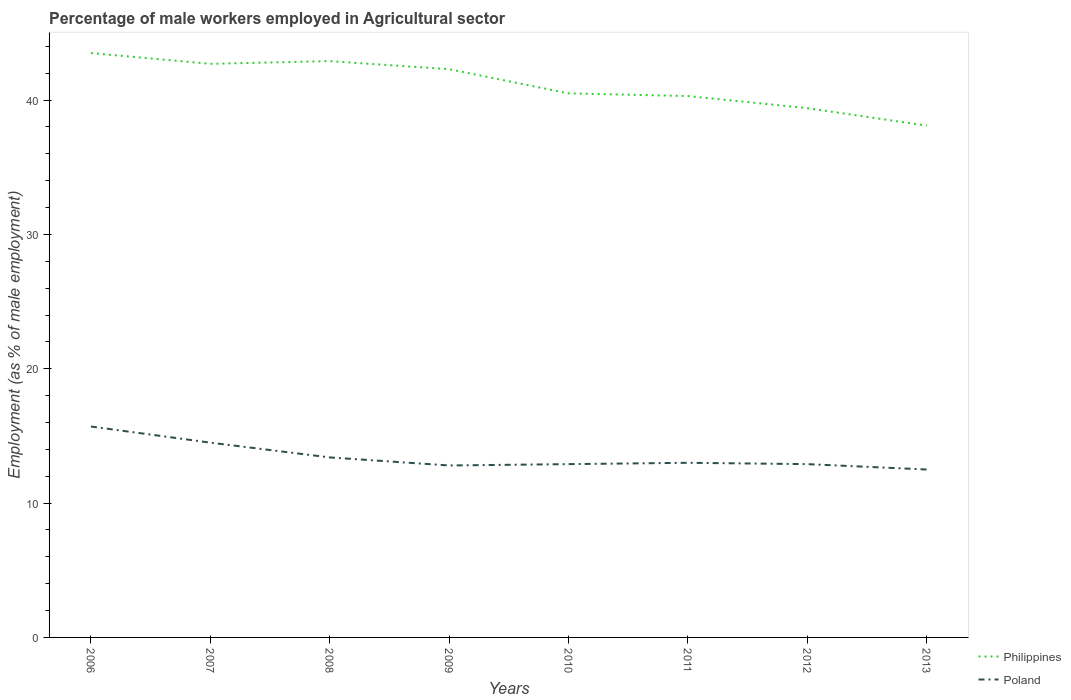How many different coloured lines are there?
Make the answer very short. 2. Is the number of lines equal to the number of legend labels?
Provide a succinct answer. Yes. Across all years, what is the maximum percentage of male workers employed in Agricultural sector in Philippines?
Ensure brevity in your answer.  38.1. What is the total percentage of male workers employed in Agricultural sector in Philippines in the graph?
Offer a very short reply. 4.1. What is the difference between the highest and the second highest percentage of male workers employed in Agricultural sector in Philippines?
Provide a succinct answer. 5.4. Is the percentage of male workers employed in Agricultural sector in Poland strictly greater than the percentage of male workers employed in Agricultural sector in Philippines over the years?
Keep it short and to the point. Yes. How many lines are there?
Keep it short and to the point. 2. How many years are there in the graph?
Offer a terse response. 8. Are the values on the major ticks of Y-axis written in scientific E-notation?
Ensure brevity in your answer.  No. Does the graph contain any zero values?
Provide a succinct answer. No. Does the graph contain grids?
Provide a succinct answer. No. How many legend labels are there?
Offer a very short reply. 2. What is the title of the graph?
Offer a very short reply. Percentage of male workers employed in Agricultural sector. Does "Timor-Leste" appear as one of the legend labels in the graph?
Offer a terse response. No. What is the label or title of the Y-axis?
Ensure brevity in your answer.  Employment (as % of male employment). What is the Employment (as % of male employment) in Philippines in 2006?
Make the answer very short. 43.5. What is the Employment (as % of male employment) in Poland in 2006?
Your answer should be compact. 15.7. What is the Employment (as % of male employment) of Philippines in 2007?
Give a very brief answer. 42.7. What is the Employment (as % of male employment) of Poland in 2007?
Provide a short and direct response. 14.5. What is the Employment (as % of male employment) in Philippines in 2008?
Your answer should be compact. 42.9. What is the Employment (as % of male employment) in Poland in 2008?
Provide a succinct answer. 13.4. What is the Employment (as % of male employment) of Philippines in 2009?
Provide a succinct answer. 42.3. What is the Employment (as % of male employment) in Poland in 2009?
Your answer should be compact. 12.8. What is the Employment (as % of male employment) in Philippines in 2010?
Provide a short and direct response. 40.5. What is the Employment (as % of male employment) in Poland in 2010?
Your answer should be compact. 12.9. What is the Employment (as % of male employment) of Philippines in 2011?
Offer a very short reply. 40.3. What is the Employment (as % of male employment) of Poland in 2011?
Give a very brief answer. 13. What is the Employment (as % of male employment) in Philippines in 2012?
Provide a succinct answer. 39.4. What is the Employment (as % of male employment) in Poland in 2012?
Provide a succinct answer. 12.9. What is the Employment (as % of male employment) in Philippines in 2013?
Provide a succinct answer. 38.1. Across all years, what is the maximum Employment (as % of male employment) in Philippines?
Offer a terse response. 43.5. Across all years, what is the maximum Employment (as % of male employment) of Poland?
Offer a terse response. 15.7. Across all years, what is the minimum Employment (as % of male employment) of Philippines?
Offer a very short reply. 38.1. Across all years, what is the minimum Employment (as % of male employment) in Poland?
Ensure brevity in your answer.  12.5. What is the total Employment (as % of male employment) in Philippines in the graph?
Provide a succinct answer. 329.7. What is the total Employment (as % of male employment) in Poland in the graph?
Give a very brief answer. 107.7. What is the difference between the Employment (as % of male employment) of Philippines in 2006 and that in 2007?
Offer a very short reply. 0.8. What is the difference between the Employment (as % of male employment) of Poland in 2006 and that in 2008?
Your response must be concise. 2.3. What is the difference between the Employment (as % of male employment) of Philippines in 2006 and that in 2009?
Provide a short and direct response. 1.2. What is the difference between the Employment (as % of male employment) of Poland in 2006 and that in 2010?
Your answer should be very brief. 2.8. What is the difference between the Employment (as % of male employment) of Philippines in 2006 and that in 2011?
Your answer should be compact. 3.2. What is the difference between the Employment (as % of male employment) in Philippines in 2006 and that in 2012?
Offer a very short reply. 4.1. What is the difference between the Employment (as % of male employment) of Philippines in 2006 and that in 2013?
Offer a very short reply. 5.4. What is the difference between the Employment (as % of male employment) in Poland in 2007 and that in 2009?
Provide a short and direct response. 1.7. What is the difference between the Employment (as % of male employment) of Philippines in 2007 and that in 2010?
Offer a terse response. 2.2. What is the difference between the Employment (as % of male employment) in Poland in 2007 and that in 2010?
Provide a short and direct response. 1.6. What is the difference between the Employment (as % of male employment) of Philippines in 2007 and that in 2011?
Ensure brevity in your answer.  2.4. What is the difference between the Employment (as % of male employment) of Poland in 2007 and that in 2011?
Make the answer very short. 1.5. What is the difference between the Employment (as % of male employment) in Poland in 2007 and that in 2012?
Give a very brief answer. 1.6. What is the difference between the Employment (as % of male employment) in Poland in 2007 and that in 2013?
Provide a succinct answer. 2. What is the difference between the Employment (as % of male employment) of Philippines in 2008 and that in 2009?
Your response must be concise. 0.6. What is the difference between the Employment (as % of male employment) of Poland in 2008 and that in 2009?
Make the answer very short. 0.6. What is the difference between the Employment (as % of male employment) in Poland in 2008 and that in 2010?
Your answer should be compact. 0.5. What is the difference between the Employment (as % of male employment) of Philippines in 2008 and that in 2011?
Offer a very short reply. 2.6. What is the difference between the Employment (as % of male employment) in Poland in 2008 and that in 2011?
Provide a short and direct response. 0.4. What is the difference between the Employment (as % of male employment) in Philippines in 2008 and that in 2012?
Keep it short and to the point. 3.5. What is the difference between the Employment (as % of male employment) of Poland in 2008 and that in 2012?
Ensure brevity in your answer.  0.5. What is the difference between the Employment (as % of male employment) in Philippines in 2008 and that in 2013?
Give a very brief answer. 4.8. What is the difference between the Employment (as % of male employment) in Poland in 2008 and that in 2013?
Your answer should be very brief. 0.9. What is the difference between the Employment (as % of male employment) of Poland in 2009 and that in 2010?
Keep it short and to the point. -0.1. What is the difference between the Employment (as % of male employment) of Philippines in 2009 and that in 2011?
Offer a terse response. 2. What is the difference between the Employment (as % of male employment) of Philippines in 2009 and that in 2012?
Offer a very short reply. 2.9. What is the difference between the Employment (as % of male employment) of Poland in 2010 and that in 2012?
Provide a succinct answer. 0. What is the difference between the Employment (as % of male employment) of Philippines in 2010 and that in 2013?
Provide a short and direct response. 2.4. What is the difference between the Employment (as % of male employment) of Philippines in 2011 and that in 2013?
Make the answer very short. 2.2. What is the difference between the Employment (as % of male employment) in Philippines in 2012 and that in 2013?
Your response must be concise. 1.3. What is the difference between the Employment (as % of male employment) in Poland in 2012 and that in 2013?
Ensure brevity in your answer.  0.4. What is the difference between the Employment (as % of male employment) of Philippines in 2006 and the Employment (as % of male employment) of Poland in 2008?
Give a very brief answer. 30.1. What is the difference between the Employment (as % of male employment) in Philippines in 2006 and the Employment (as % of male employment) in Poland in 2009?
Provide a short and direct response. 30.7. What is the difference between the Employment (as % of male employment) of Philippines in 2006 and the Employment (as % of male employment) of Poland in 2010?
Keep it short and to the point. 30.6. What is the difference between the Employment (as % of male employment) of Philippines in 2006 and the Employment (as % of male employment) of Poland in 2011?
Provide a succinct answer. 30.5. What is the difference between the Employment (as % of male employment) in Philippines in 2006 and the Employment (as % of male employment) in Poland in 2012?
Ensure brevity in your answer.  30.6. What is the difference between the Employment (as % of male employment) of Philippines in 2007 and the Employment (as % of male employment) of Poland in 2008?
Your response must be concise. 29.3. What is the difference between the Employment (as % of male employment) of Philippines in 2007 and the Employment (as % of male employment) of Poland in 2009?
Offer a terse response. 29.9. What is the difference between the Employment (as % of male employment) in Philippines in 2007 and the Employment (as % of male employment) in Poland in 2010?
Keep it short and to the point. 29.8. What is the difference between the Employment (as % of male employment) in Philippines in 2007 and the Employment (as % of male employment) in Poland in 2011?
Ensure brevity in your answer.  29.7. What is the difference between the Employment (as % of male employment) in Philippines in 2007 and the Employment (as % of male employment) in Poland in 2012?
Keep it short and to the point. 29.8. What is the difference between the Employment (as % of male employment) of Philippines in 2007 and the Employment (as % of male employment) of Poland in 2013?
Offer a terse response. 30.2. What is the difference between the Employment (as % of male employment) of Philippines in 2008 and the Employment (as % of male employment) of Poland in 2009?
Give a very brief answer. 30.1. What is the difference between the Employment (as % of male employment) of Philippines in 2008 and the Employment (as % of male employment) of Poland in 2011?
Your response must be concise. 29.9. What is the difference between the Employment (as % of male employment) in Philippines in 2008 and the Employment (as % of male employment) in Poland in 2012?
Offer a terse response. 30. What is the difference between the Employment (as % of male employment) of Philippines in 2008 and the Employment (as % of male employment) of Poland in 2013?
Keep it short and to the point. 30.4. What is the difference between the Employment (as % of male employment) in Philippines in 2009 and the Employment (as % of male employment) in Poland in 2010?
Your answer should be compact. 29.4. What is the difference between the Employment (as % of male employment) in Philippines in 2009 and the Employment (as % of male employment) in Poland in 2011?
Your answer should be compact. 29.3. What is the difference between the Employment (as % of male employment) in Philippines in 2009 and the Employment (as % of male employment) in Poland in 2012?
Give a very brief answer. 29.4. What is the difference between the Employment (as % of male employment) of Philippines in 2009 and the Employment (as % of male employment) of Poland in 2013?
Ensure brevity in your answer.  29.8. What is the difference between the Employment (as % of male employment) in Philippines in 2010 and the Employment (as % of male employment) in Poland in 2011?
Offer a very short reply. 27.5. What is the difference between the Employment (as % of male employment) of Philippines in 2010 and the Employment (as % of male employment) of Poland in 2012?
Your answer should be very brief. 27.6. What is the difference between the Employment (as % of male employment) in Philippines in 2010 and the Employment (as % of male employment) in Poland in 2013?
Your response must be concise. 28. What is the difference between the Employment (as % of male employment) in Philippines in 2011 and the Employment (as % of male employment) in Poland in 2012?
Make the answer very short. 27.4. What is the difference between the Employment (as % of male employment) in Philippines in 2011 and the Employment (as % of male employment) in Poland in 2013?
Your answer should be compact. 27.8. What is the difference between the Employment (as % of male employment) in Philippines in 2012 and the Employment (as % of male employment) in Poland in 2013?
Ensure brevity in your answer.  26.9. What is the average Employment (as % of male employment) of Philippines per year?
Offer a very short reply. 41.21. What is the average Employment (as % of male employment) in Poland per year?
Ensure brevity in your answer.  13.46. In the year 2006, what is the difference between the Employment (as % of male employment) of Philippines and Employment (as % of male employment) of Poland?
Give a very brief answer. 27.8. In the year 2007, what is the difference between the Employment (as % of male employment) in Philippines and Employment (as % of male employment) in Poland?
Keep it short and to the point. 28.2. In the year 2008, what is the difference between the Employment (as % of male employment) of Philippines and Employment (as % of male employment) of Poland?
Ensure brevity in your answer.  29.5. In the year 2009, what is the difference between the Employment (as % of male employment) of Philippines and Employment (as % of male employment) of Poland?
Provide a succinct answer. 29.5. In the year 2010, what is the difference between the Employment (as % of male employment) of Philippines and Employment (as % of male employment) of Poland?
Offer a very short reply. 27.6. In the year 2011, what is the difference between the Employment (as % of male employment) of Philippines and Employment (as % of male employment) of Poland?
Your response must be concise. 27.3. In the year 2012, what is the difference between the Employment (as % of male employment) in Philippines and Employment (as % of male employment) in Poland?
Offer a terse response. 26.5. In the year 2013, what is the difference between the Employment (as % of male employment) in Philippines and Employment (as % of male employment) in Poland?
Your answer should be very brief. 25.6. What is the ratio of the Employment (as % of male employment) of Philippines in 2006 to that in 2007?
Ensure brevity in your answer.  1.02. What is the ratio of the Employment (as % of male employment) in Poland in 2006 to that in 2007?
Make the answer very short. 1.08. What is the ratio of the Employment (as % of male employment) of Philippines in 2006 to that in 2008?
Your response must be concise. 1.01. What is the ratio of the Employment (as % of male employment) in Poland in 2006 to that in 2008?
Provide a short and direct response. 1.17. What is the ratio of the Employment (as % of male employment) in Philippines in 2006 to that in 2009?
Ensure brevity in your answer.  1.03. What is the ratio of the Employment (as % of male employment) of Poland in 2006 to that in 2009?
Give a very brief answer. 1.23. What is the ratio of the Employment (as % of male employment) of Philippines in 2006 to that in 2010?
Keep it short and to the point. 1.07. What is the ratio of the Employment (as % of male employment) in Poland in 2006 to that in 2010?
Provide a succinct answer. 1.22. What is the ratio of the Employment (as % of male employment) of Philippines in 2006 to that in 2011?
Your answer should be compact. 1.08. What is the ratio of the Employment (as % of male employment) in Poland in 2006 to that in 2011?
Keep it short and to the point. 1.21. What is the ratio of the Employment (as % of male employment) of Philippines in 2006 to that in 2012?
Provide a succinct answer. 1.1. What is the ratio of the Employment (as % of male employment) of Poland in 2006 to that in 2012?
Make the answer very short. 1.22. What is the ratio of the Employment (as % of male employment) of Philippines in 2006 to that in 2013?
Keep it short and to the point. 1.14. What is the ratio of the Employment (as % of male employment) of Poland in 2006 to that in 2013?
Provide a succinct answer. 1.26. What is the ratio of the Employment (as % of male employment) in Poland in 2007 to that in 2008?
Your response must be concise. 1.08. What is the ratio of the Employment (as % of male employment) in Philippines in 2007 to that in 2009?
Give a very brief answer. 1.01. What is the ratio of the Employment (as % of male employment) in Poland in 2007 to that in 2009?
Make the answer very short. 1.13. What is the ratio of the Employment (as % of male employment) of Philippines in 2007 to that in 2010?
Provide a short and direct response. 1.05. What is the ratio of the Employment (as % of male employment) of Poland in 2007 to that in 2010?
Make the answer very short. 1.12. What is the ratio of the Employment (as % of male employment) of Philippines in 2007 to that in 2011?
Make the answer very short. 1.06. What is the ratio of the Employment (as % of male employment) of Poland in 2007 to that in 2011?
Offer a terse response. 1.12. What is the ratio of the Employment (as % of male employment) in Philippines in 2007 to that in 2012?
Provide a short and direct response. 1.08. What is the ratio of the Employment (as % of male employment) of Poland in 2007 to that in 2012?
Provide a succinct answer. 1.12. What is the ratio of the Employment (as % of male employment) of Philippines in 2007 to that in 2013?
Keep it short and to the point. 1.12. What is the ratio of the Employment (as % of male employment) of Poland in 2007 to that in 2013?
Your answer should be compact. 1.16. What is the ratio of the Employment (as % of male employment) in Philippines in 2008 to that in 2009?
Provide a short and direct response. 1.01. What is the ratio of the Employment (as % of male employment) in Poland in 2008 to that in 2009?
Your response must be concise. 1.05. What is the ratio of the Employment (as % of male employment) in Philippines in 2008 to that in 2010?
Your answer should be very brief. 1.06. What is the ratio of the Employment (as % of male employment) in Poland in 2008 to that in 2010?
Offer a terse response. 1.04. What is the ratio of the Employment (as % of male employment) in Philippines in 2008 to that in 2011?
Provide a short and direct response. 1.06. What is the ratio of the Employment (as % of male employment) of Poland in 2008 to that in 2011?
Make the answer very short. 1.03. What is the ratio of the Employment (as % of male employment) in Philippines in 2008 to that in 2012?
Your response must be concise. 1.09. What is the ratio of the Employment (as % of male employment) of Poland in 2008 to that in 2012?
Your answer should be compact. 1.04. What is the ratio of the Employment (as % of male employment) in Philippines in 2008 to that in 2013?
Offer a terse response. 1.13. What is the ratio of the Employment (as % of male employment) of Poland in 2008 to that in 2013?
Offer a very short reply. 1.07. What is the ratio of the Employment (as % of male employment) in Philippines in 2009 to that in 2010?
Ensure brevity in your answer.  1.04. What is the ratio of the Employment (as % of male employment) of Poland in 2009 to that in 2010?
Offer a very short reply. 0.99. What is the ratio of the Employment (as % of male employment) in Philippines in 2009 to that in 2011?
Offer a very short reply. 1.05. What is the ratio of the Employment (as % of male employment) in Poland in 2009 to that in 2011?
Your answer should be compact. 0.98. What is the ratio of the Employment (as % of male employment) in Philippines in 2009 to that in 2012?
Provide a short and direct response. 1.07. What is the ratio of the Employment (as % of male employment) in Poland in 2009 to that in 2012?
Provide a short and direct response. 0.99. What is the ratio of the Employment (as % of male employment) of Philippines in 2009 to that in 2013?
Offer a very short reply. 1.11. What is the ratio of the Employment (as % of male employment) in Poland in 2009 to that in 2013?
Keep it short and to the point. 1.02. What is the ratio of the Employment (as % of male employment) of Philippines in 2010 to that in 2012?
Make the answer very short. 1.03. What is the ratio of the Employment (as % of male employment) in Philippines in 2010 to that in 2013?
Your response must be concise. 1.06. What is the ratio of the Employment (as % of male employment) in Poland in 2010 to that in 2013?
Ensure brevity in your answer.  1.03. What is the ratio of the Employment (as % of male employment) in Philippines in 2011 to that in 2012?
Keep it short and to the point. 1.02. What is the ratio of the Employment (as % of male employment) of Philippines in 2011 to that in 2013?
Offer a terse response. 1.06. What is the ratio of the Employment (as % of male employment) in Philippines in 2012 to that in 2013?
Provide a short and direct response. 1.03. What is the ratio of the Employment (as % of male employment) of Poland in 2012 to that in 2013?
Keep it short and to the point. 1.03. What is the difference between the highest and the second highest Employment (as % of male employment) of Poland?
Your response must be concise. 1.2. What is the difference between the highest and the lowest Employment (as % of male employment) in Philippines?
Provide a succinct answer. 5.4. 